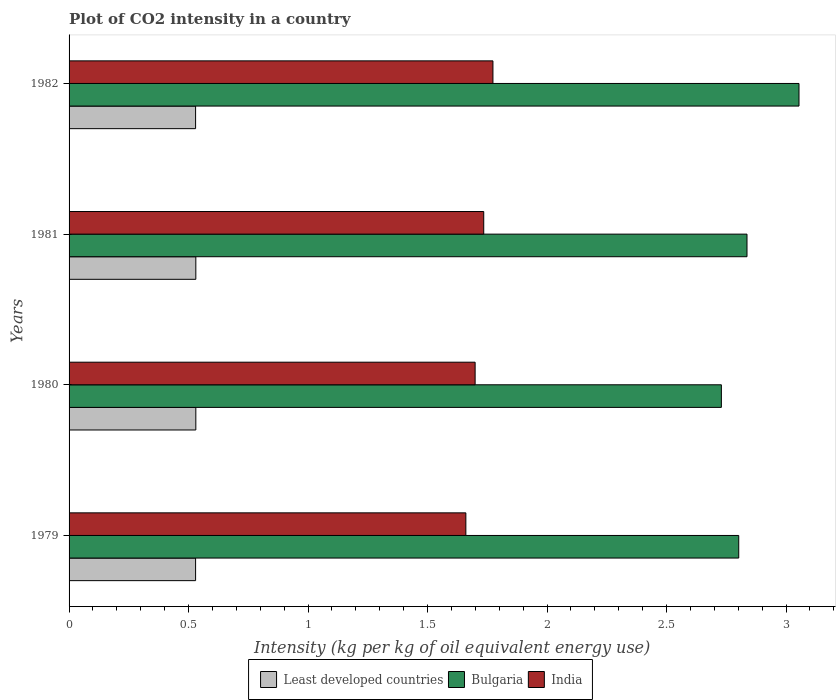How many different coloured bars are there?
Offer a terse response. 3. Are the number of bars per tick equal to the number of legend labels?
Keep it short and to the point. Yes. Are the number of bars on each tick of the Y-axis equal?
Provide a short and direct response. Yes. How many bars are there on the 1st tick from the top?
Make the answer very short. 3. In how many cases, is the number of bars for a given year not equal to the number of legend labels?
Offer a terse response. 0. What is the CO2 intensity in in Bulgaria in 1980?
Give a very brief answer. 2.73. Across all years, what is the maximum CO2 intensity in in Least developed countries?
Make the answer very short. 0.53. Across all years, what is the minimum CO2 intensity in in Least developed countries?
Your response must be concise. 0.53. In which year was the CO2 intensity in in Least developed countries minimum?
Keep it short and to the point. 1979. What is the total CO2 intensity in in Least developed countries in the graph?
Provide a succinct answer. 2.12. What is the difference between the CO2 intensity in in India in 1980 and that in 1982?
Offer a very short reply. -0.07. What is the difference between the CO2 intensity in in Bulgaria in 1980 and the CO2 intensity in in India in 1982?
Provide a short and direct response. 0.96. What is the average CO2 intensity in in India per year?
Your response must be concise. 1.72. In the year 1980, what is the difference between the CO2 intensity in in India and CO2 intensity in in Least developed countries?
Offer a very short reply. 1.17. What is the ratio of the CO2 intensity in in India in 1980 to that in 1981?
Provide a succinct answer. 0.98. Is the CO2 intensity in in India in 1979 less than that in 1981?
Keep it short and to the point. Yes. What is the difference between the highest and the second highest CO2 intensity in in India?
Provide a short and direct response. 0.04. What is the difference between the highest and the lowest CO2 intensity in in Bulgaria?
Your answer should be compact. 0.32. In how many years, is the CO2 intensity in in Least developed countries greater than the average CO2 intensity in in Least developed countries taken over all years?
Make the answer very short. 2. Is the sum of the CO2 intensity in in Bulgaria in 1980 and 1982 greater than the maximum CO2 intensity in in India across all years?
Keep it short and to the point. Yes. Is it the case that in every year, the sum of the CO2 intensity in in Least developed countries and CO2 intensity in in Bulgaria is greater than the CO2 intensity in in India?
Your answer should be very brief. Yes. How many bars are there?
Ensure brevity in your answer.  12. How many years are there in the graph?
Offer a very short reply. 4. Are the values on the major ticks of X-axis written in scientific E-notation?
Provide a succinct answer. No. Does the graph contain grids?
Give a very brief answer. No. Where does the legend appear in the graph?
Your answer should be very brief. Bottom center. How many legend labels are there?
Keep it short and to the point. 3. What is the title of the graph?
Make the answer very short. Plot of CO2 intensity in a country. What is the label or title of the X-axis?
Give a very brief answer. Intensity (kg per kg of oil equivalent energy use). What is the label or title of the Y-axis?
Offer a terse response. Years. What is the Intensity (kg per kg of oil equivalent energy use) in Least developed countries in 1979?
Offer a terse response. 0.53. What is the Intensity (kg per kg of oil equivalent energy use) of Bulgaria in 1979?
Provide a short and direct response. 2.8. What is the Intensity (kg per kg of oil equivalent energy use) of India in 1979?
Your response must be concise. 1.66. What is the Intensity (kg per kg of oil equivalent energy use) in Least developed countries in 1980?
Your response must be concise. 0.53. What is the Intensity (kg per kg of oil equivalent energy use) in Bulgaria in 1980?
Your response must be concise. 2.73. What is the Intensity (kg per kg of oil equivalent energy use) in India in 1980?
Make the answer very short. 1.7. What is the Intensity (kg per kg of oil equivalent energy use) of Least developed countries in 1981?
Provide a succinct answer. 0.53. What is the Intensity (kg per kg of oil equivalent energy use) in Bulgaria in 1981?
Offer a very short reply. 2.84. What is the Intensity (kg per kg of oil equivalent energy use) in India in 1981?
Make the answer very short. 1.74. What is the Intensity (kg per kg of oil equivalent energy use) of Least developed countries in 1982?
Provide a succinct answer. 0.53. What is the Intensity (kg per kg of oil equivalent energy use) of Bulgaria in 1982?
Your answer should be compact. 3.05. What is the Intensity (kg per kg of oil equivalent energy use) in India in 1982?
Your answer should be very brief. 1.77. Across all years, what is the maximum Intensity (kg per kg of oil equivalent energy use) in Least developed countries?
Your answer should be compact. 0.53. Across all years, what is the maximum Intensity (kg per kg of oil equivalent energy use) of Bulgaria?
Offer a terse response. 3.05. Across all years, what is the maximum Intensity (kg per kg of oil equivalent energy use) of India?
Make the answer very short. 1.77. Across all years, what is the minimum Intensity (kg per kg of oil equivalent energy use) in Least developed countries?
Keep it short and to the point. 0.53. Across all years, what is the minimum Intensity (kg per kg of oil equivalent energy use) of Bulgaria?
Your answer should be compact. 2.73. Across all years, what is the minimum Intensity (kg per kg of oil equivalent energy use) of India?
Give a very brief answer. 1.66. What is the total Intensity (kg per kg of oil equivalent energy use) in Least developed countries in the graph?
Your response must be concise. 2.12. What is the total Intensity (kg per kg of oil equivalent energy use) of Bulgaria in the graph?
Keep it short and to the point. 11.42. What is the total Intensity (kg per kg of oil equivalent energy use) in India in the graph?
Your response must be concise. 6.87. What is the difference between the Intensity (kg per kg of oil equivalent energy use) in Least developed countries in 1979 and that in 1980?
Make the answer very short. -0. What is the difference between the Intensity (kg per kg of oil equivalent energy use) in Bulgaria in 1979 and that in 1980?
Your response must be concise. 0.07. What is the difference between the Intensity (kg per kg of oil equivalent energy use) in India in 1979 and that in 1980?
Offer a very short reply. -0.04. What is the difference between the Intensity (kg per kg of oil equivalent energy use) in Least developed countries in 1979 and that in 1981?
Your response must be concise. -0. What is the difference between the Intensity (kg per kg of oil equivalent energy use) of Bulgaria in 1979 and that in 1981?
Offer a very short reply. -0.03. What is the difference between the Intensity (kg per kg of oil equivalent energy use) in India in 1979 and that in 1981?
Offer a terse response. -0.07. What is the difference between the Intensity (kg per kg of oil equivalent energy use) of Bulgaria in 1979 and that in 1982?
Give a very brief answer. -0.25. What is the difference between the Intensity (kg per kg of oil equivalent energy use) of India in 1979 and that in 1982?
Offer a very short reply. -0.11. What is the difference between the Intensity (kg per kg of oil equivalent energy use) of Bulgaria in 1980 and that in 1981?
Your answer should be compact. -0.11. What is the difference between the Intensity (kg per kg of oil equivalent energy use) of India in 1980 and that in 1981?
Provide a short and direct response. -0.04. What is the difference between the Intensity (kg per kg of oil equivalent energy use) in Least developed countries in 1980 and that in 1982?
Provide a succinct answer. 0. What is the difference between the Intensity (kg per kg of oil equivalent energy use) of Bulgaria in 1980 and that in 1982?
Your answer should be very brief. -0.32. What is the difference between the Intensity (kg per kg of oil equivalent energy use) in India in 1980 and that in 1982?
Make the answer very short. -0.07. What is the difference between the Intensity (kg per kg of oil equivalent energy use) of Least developed countries in 1981 and that in 1982?
Offer a very short reply. 0. What is the difference between the Intensity (kg per kg of oil equivalent energy use) of Bulgaria in 1981 and that in 1982?
Keep it short and to the point. -0.22. What is the difference between the Intensity (kg per kg of oil equivalent energy use) of India in 1981 and that in 1982?
Offer a very short reply. -0.04. What is the difference between the Intensity (kg per kg of oil equivalent energy use) in Least developed countries in 1979 and the Intensity (kg per kg of oil equivalent energy use) in Bulgaria in 1980?
Your response must be concise. -2.2. What is the difference between the Intensity (kg per kg of oil equivalent energy use) of Least developed countries in 1979 and the Intensity (kg per kg of oil equivalent energy use) of India in 1980?
Give a very brief answer. -1.17. What is the difference between the Intensity (kg per kg of oil equivalent energy use) of Bulgaria in 1979 and the Intensity (kg per kg of oil equivalent energy use) of India in 1980?
Your answer should be very brief. 1.1. What is the difference between the Intensity (kg per kg of oil equivalent energy use) in Least developed countries in 1979 and the Intensity (kg per kg of oil equivalent energy use) in Bulgaria in 1981?
Provide a short and direct response. -2.31. What is the difference between the Intensity (kg per kg of oil equivalent energy use) in Least developed countries in 1979 and the Intensity (kg per kg of oil equivalent energy use) in India in 1981?
Your answer should be compact. -1.21. What is the difference between the Intensity (kg per kg of oil equivalent energy use) of Bulgaria in 1979 and the Intensity (kg per kg of oil equivalent energy use) of India in 1981?
Offer a very short reply. 1.07. What is the difference between the Intensity (kg per kg of oil equivalent energy use) of Least developed countries in 1979 and the Intensity (kg per kg of oil equivalent energy use) of Bulgaria in 1982?
Keep it short and to the point. -2.52. What is the difference between the Intensity (kg per kg of oil equivalent energy use) in Least developed countries in 1979 and the Intensity (kg per kg of oil equivalent energy use) in India in 1982?
Provide a short and direct response. -1.24. What is the difference between the Intensity (kg per kg of oil equivalent energy use) in Bulgaria in 1979 and the Intensity (kg per kg of oil equivalent energy use) in India in 1982?
Provide a short and direct response. 1.03. What is the difference between the Intensity (kg per kg of oil equivalent energy use) in Least developed countries in 1980 and the Intensity (kg per kg of oil equivalent energy use) in Bulgaria in 1981?
Provide a succinct answer. -2.31. What is the difference between the Intensity (kg per kg of oil equivalent energy use) of Least developed countries in 1980 and the Intensity (kg per kg of oil equivalent energy use) of India in 1981?
Ensure brevity in your answer.  -1.2. What is the difference between the Intensity (kg per kg of oil equivalent energy use) of Bulgaria in 1980 and the Intensity (kg per kg of oil equivalent energy use) of India in 1981?
Offer a terse response. 0.99. What is the difference between the Intensity (kg per kg of oil equivalent energy use) in Least developed countries in 1980 and the Intensity (kg per kg of oil equivalent energy use) in Bulgaria in 1982?
Make the answer very short. -2.52. What is the difference between the Intensity (kg per kg of oil equivalent energy use) in Least developed countries in 1980 and the Intensity (kg per kg of oil equivalent energy use) in India in 1982?
Provide a short and direct response. -1.24. What is the difference between the Intensity (kg per kg of oil equivalent energy use) of Bulgaria in 1980 and the Intensity (kg per kg of oil equivalent energy use) of India in 1982?
Your answer should be compact. 0.96. What is the difference between the Intensity (kg per kg of oil equivalent energy use) of Least developed countries in 1981 and the Intensity (kg per kg of oil equivalent energy use) of Bulgaria in 1982?
Make the answer very short. -2.52. What is the difference between the Intensity (kg per kg of oil equivalent energy use) in Least developed countries in 1981 and the Intensity (kg per kg of oil equivalent energy use) in India in 1982?
Make the answer very short. -1.24. What is the difference between the Intensity (kg per kg of oil equivalent energy use) in Bulgaria in 1981 and the Intensity (kg per kg of oil equivalent energy use) in India in 1982?
Offer a very short reply. 1.06. What is the average Intensity (kg per kg of oil equivalent energy use) in Least developed countries per year?
Give a very brief answer. 0.53. What is the average Intensity (kg per kg of oil equivalent energy use) of Bulgaria per year?
Your response must be concise. 2.86. What is the average Intensity (kg per kg of oil equivalent energy use) of India per year?
Make the answer very short. 1.72. In the year 1979, what is the difference between the Intensity (kg per kg of oil equivalent energy use) in Least developed countries and Intensity (kg per kg of oil equivalent energy use) in Bulgaria?
Provide a short and direct response. -2.27. In the year 1979, what is the difference between the Intensity (kg per kg of oil equivalent energy use) in Least developed countries and Intensity (kg per kg of oil equivalent energy use) in India?
Your answer should be very brief. -1.13. In the year 1979, what is the difference between the Intensity (kg per kg of oil equivalent energy use) in Bulgaria and Intensity (kg per kg of oil equivalent energy use) in India?
Keep it short and to the point. 1.14. In the year 1980, what is the difference between the Intensity (kg per kg of oil equivalent energy use) in Least developed countries and Intensity (kg per kg of oil equivalent energy use) in Bulgaria?
Make the answer very short. -2.2. In the year 1980, what is the difference between the Intensity (kg per kg of oil equivalent energy use) of Least developed countries and Intensity (kg per kg of oil equivalent energy use) of India?
Make the answer very short. -1.17. In the year 1980, what is the difference between the Intensity (kg per kg of oil equivalent energy use) of Bulgaria and Intensity (kg per kg of oil equivalent energy use) of India?
Give a very brief answer. 1.03. In the year 1981, what is the difference between the Intensity (kg per kg of oil equivalent energy use) of Least developed countries and Intensity (kg per kg of oil equivalent energy use) of Bulgaria?
Make the answer very short. -2.31. In the year 1981, what is the difference between the Intensity (kg per kg of oil equivalent energy use) of Least developed countries and Intensity (kg per kg of oil equivalent energy use) of India?
Ensure brevity in your answer.  -1.2. In the year 1981, what is the difference between the Intensity (kg per kg of oil equivalent energy use) in Bulgaria and Intensity (kg per kg of oil equivalent energy use) in India?
Offer a very short reply. 1.1. In the year 1982, what is the difference between the Intensity (kg per kg of oil equivalent energy use) of Least developed countries and Intensity (kg per kg of oil equivalent energy use) of Bulgaria?
Your response must be concise. -2.52. In the year 1982, what is the difference between the Intensity (kg per kg of oil equivalent energy use) of Least developed countries and Intensity (kg per kg of oil equivalent energy use) of India?
Offer a terse response. -1.24. In the year 1982, what is the difference between the Intensity (kg per kg of oil equivalent energy use) in Bulgaria and Intensity (kg per kg of oil equivalent energy use) in India?
Offer a very short reply. 1.28. What is the ratio of the Intensity (kg per kg of oil equivalent energy use) of Least developed countries in 1979 to that in 1980?
Your answer should be very brief. 1. What is the ratio of the Intensity (kg per kg of oil equivalent energy use) of Bulgaria in 1979 to that in 1980?
Your answer should be very brief. 1.03. What is the ratio of the Intensity (kg per kg of oil equivalent energy use) in India in 1979 to that in 1980?
Make the answer very short. 0.98. What is the ratio of the Intensity (kg per kg of oil equivalent energy use) in Least developed countries in 1979 to that in 1981?
Your response must be concise. 1. What is the ratio of the Intensity (kg per kg of oil equivalent energy use) of Bulgaria in 1979 to that in 1981?
Your response must be concise. 0.99. What is the ratio of the Intensity (kg per kg of oil equivalent energy use) of India in 1979 to that in 1981?
Make the answer very short. 0.96. What is the ratio of the Intensity (kg per kg of oil equivalent energy use) of Least developed countries in 1979 to that in 1982?
Make the answer very short. 1. What is the ratio of the Intensity (kg per kg of oil equivalent energy use) of Bulgaria in 1979 to that in 1982?
Provide a succinct answer. 0.92. What is the ratio of the Intensity (kg per kg of oil equivalent energy use) in India in 1979 to that in 1982?
Offer a very short reply. 0.94. What is the ratio of the Intensity (kg per kg of oil equivalent energy use) of Bulgaria in 1980 to that in 1981?
Your answer should be very brief. 0.96. What is the ratio of the Intensity (kg per kg of oil equivalent energy use) of India in 1980 to that in 1981?
Your answer should be very brief. 0.98. What is the ratio of the Intensity (kg per kg of oil equivalent energy use) in Bulgaria in 1980 to that in 1982?
Provide a short and direct response. 0.89. What is the ratio of the Intensity (kg per kg of oil equivalent energy use) in India in 1980 to that in 1982?
Ensure brevity in your answer.  0.96. What is the ratio of the Intensity (kg per kg of oil equivalent energy use) of Bulgaria in 1981 to that in 1982?
Your answer should be very brief. 0.93. What is the ratio of the Intensity (kg per kg of oil equivalent energy use) of India in 1981 to that in 1982?
Offer a very short reply. 0.98. What is the difference between the highest and the second highest Intensity (kg per kg of oil equivalent energy use) of Bulgaria?
Offer a very short reply. 0.22. What is the difference between the highest and the second highest Intensity (kg per kg of oil equivalent energy use) of India?
Offer a terse response. 0.04. What is the difference between the highest and the lowest Intensity (kg per kg of oil equivalent energy use) of Bulgaria?
Your response must be concise. 0.32. What is the difference between the highest and the lowest Intensity (kg per kg of oil equivalent energy use) of India?
Offer a terse response. 0.11. 